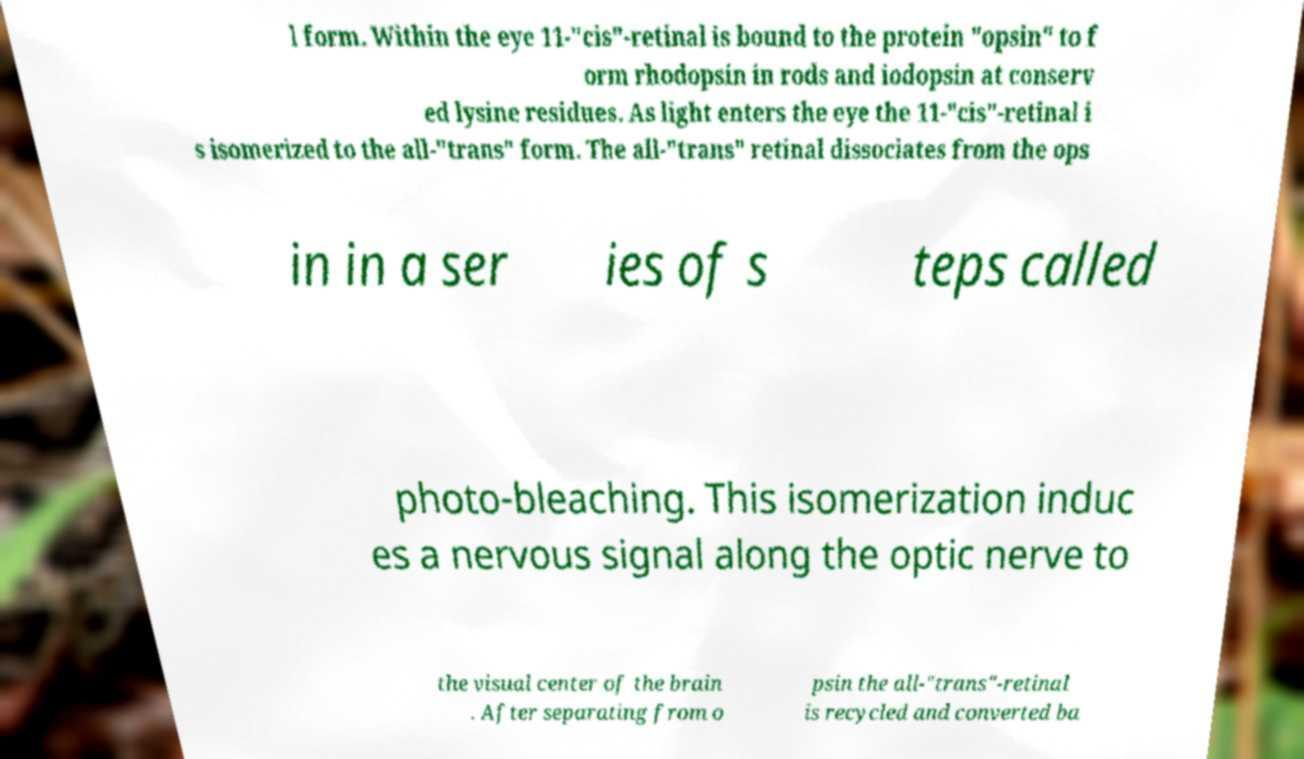Please identify and transcribe the text found in this image. l form. Within the eye 11-"cis"-retinal is bound to the protein "opsin" to f orm rhodopsin in rods and iodopsin at conserv ed lysine residues. As light enters the eye the 11-"cis"-retinal i s isomerized to the all-"trans" form. The all-"trans" retinal dissociates from the ops in in a ser ies of s teps called photo-bleaching. This isomerization induc es a nervous signal along the optic nerve to the visual center of the brain . After separating from o psin the all-"trans"-retinal is recycled and converted ba 